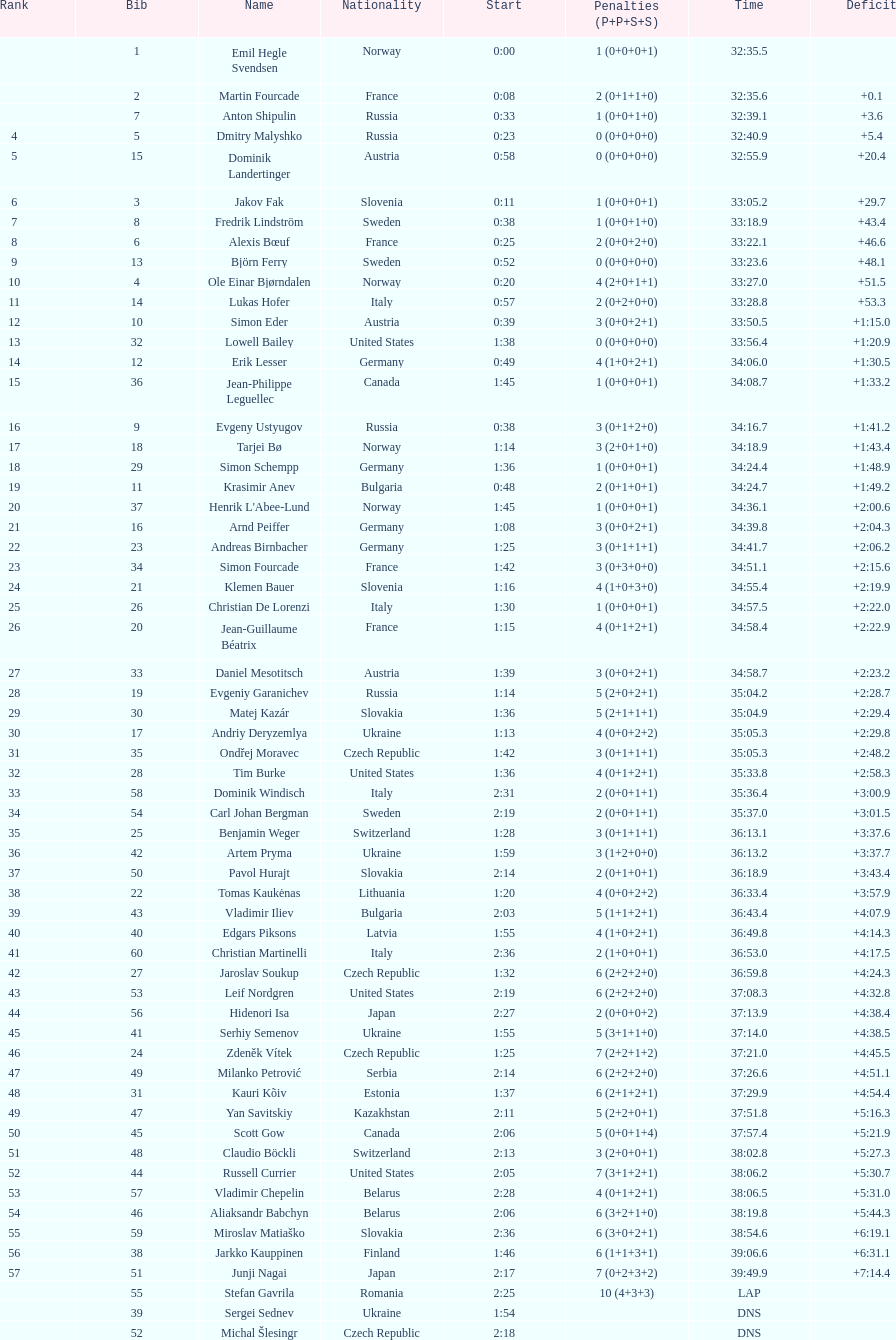How many competitors from the united states failed to win medals? 4. 